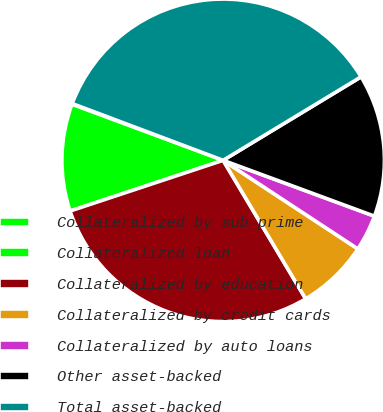Convert chart to OTSL. <chart><loc_0><loc_0><loc_500><loc_500><pie_chart><fcel>Collateralized by sub-prime<fcel>Collateralized loan<fcel>Collateralized by education<fcel>Collateralized by credit cards<fcel>Collateralized by auto loans<fcel>Other asset-backed<fcel>Total asset-backed<nl><fcel>0.08%<fcel>10.74%<fcel>28.46%<fcel>7.19%<fcel>3.63%<fcel>14.29%<fcel>35.61%<nl></chart> 